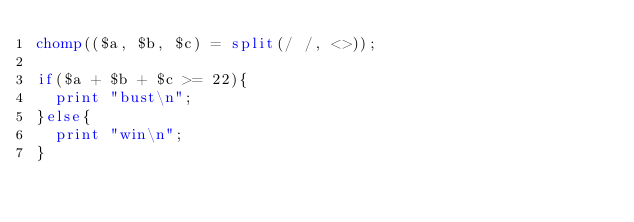<code> <loc_0><loc_0><loc_500><loc_500><_Perl_>chomp(($a, $b, $c) = split(/ /, <>));

if($a + $b + $c >= 22){
	print "bust\n";
}else{
	print "win\n";
}
</code> 